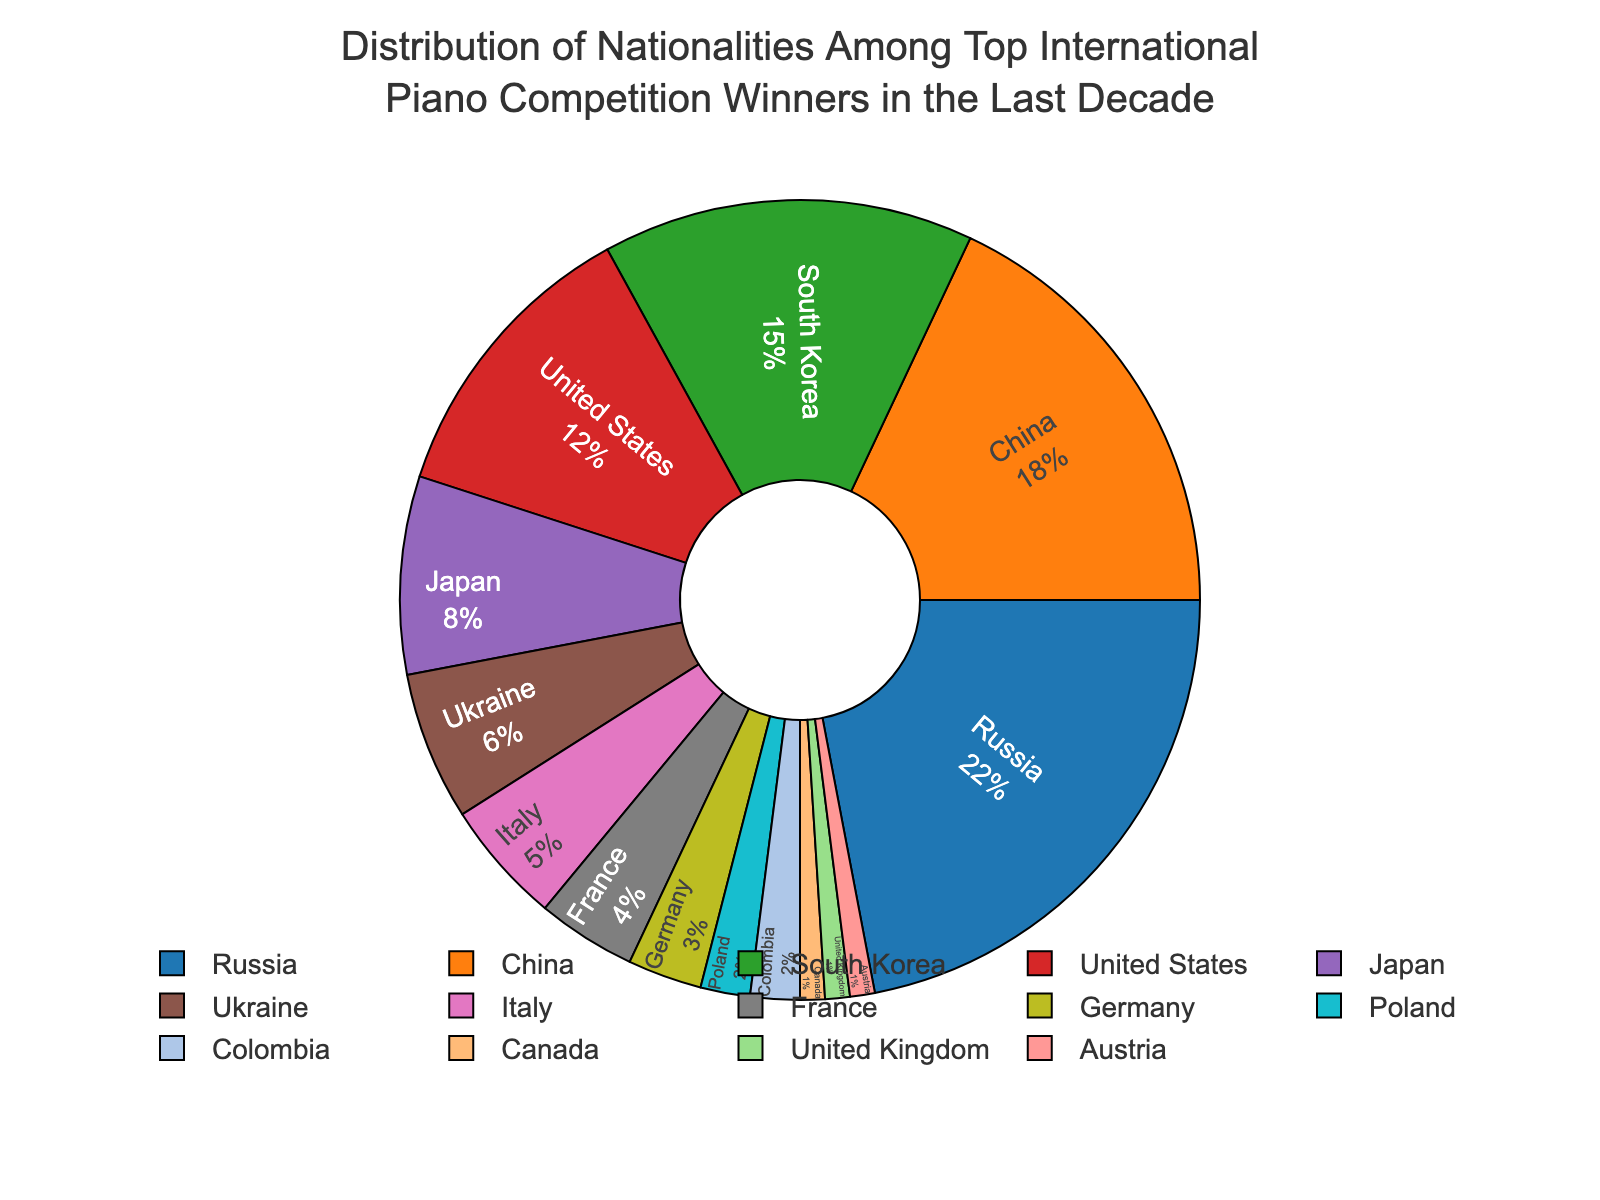Which nationality has the highest percentage of top international piano competition winners in the last decade? From the pie chart, we can see that Russia has the largest section. The label indicates a percentage of 22%.
Answer: Russia Which two nationalities have the smallest percentage of winners? By observing the smallest sections of the pie chart, the United Kingdom and Austria have the smallest sections, both labeled at 1%.
Answer: United Kingdom and Austria What is the combined percentage of winners from China and South Korea? The percentage for China is 18% and for South Korea is 15%. Adding these two percentages together, we get 18% + 15% = 33%.
Answer: 33% How does the percentage of winners from Japan compare to that of Ukraine? From the chart, Japan has 8% and Ukraine has 6%. Comparing these numbers, we see that Japan has a higher percentage than Ukraine.
Answer: Japan has a higher percentage What is the percentage difference between the United States and Italy? The United States has 12% and Italy has 5%. Subtracting these gives us 12% - 5% = 7%.
Answer: 7% What percentage of winners are from European countries? Adding the percentages for Russia (22%), Ukraine (6%), Italy (5%), France (4%), Germany (3%), Poland (2%), United Kingdom (1%), and Austria (1%) gives us 22% + 6% + 5% + 4% + 3% + 2% + 1% + 1% = 44%.
Answer: 44% Which country in the Americas has the highest percentage of winners? Countries in the Americas visible in the chart include the United States (12%) and Canada (1%). Thus, the United States has the highest percentage.
Answer: United States Are there more winners from Asian countries or European countries? Summing the percentages for Asian countries: China (18%), South Korea (15%), Japan (8%) equals 18% + 15% + 8% = 41%. For European countries: Russia (22%), Ukraine (6%), Italy (5%), France (4%), Germany (3%), Poland (2%), United Kingdom (1%), Austria (1%) equals 22% + 6% + 5% + 4% + 3% + 2% + 1% + 1% = 44%. Thus, there are more winners from European countries.
Answer: European countries What is the percentage of winners from countries other than the top five nationalities listed? The top five nationalities are Russia (22%), China (18%), South Korea (15%), United States (12%), and Japan (8%), which together make up 22% + 18% + 15% + 12% + 8% = 75%. Subtracting from 100%, we get 100% - 75% = 25%.
Answer: 25% 